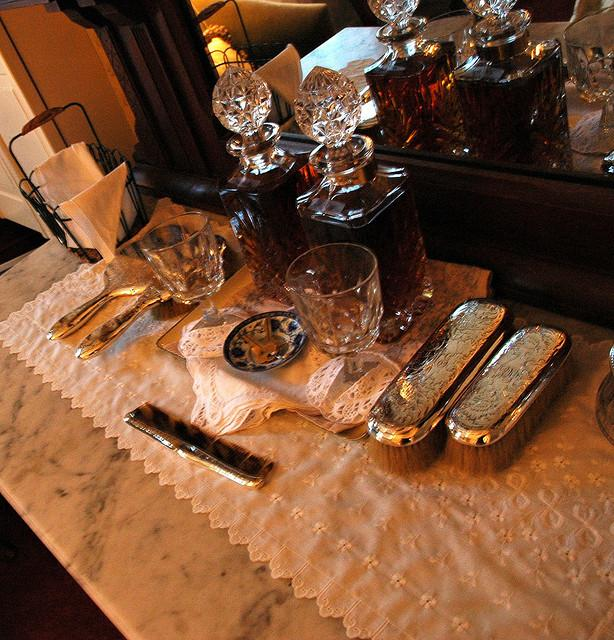What is most likely in the glass with the round top? alcohol 